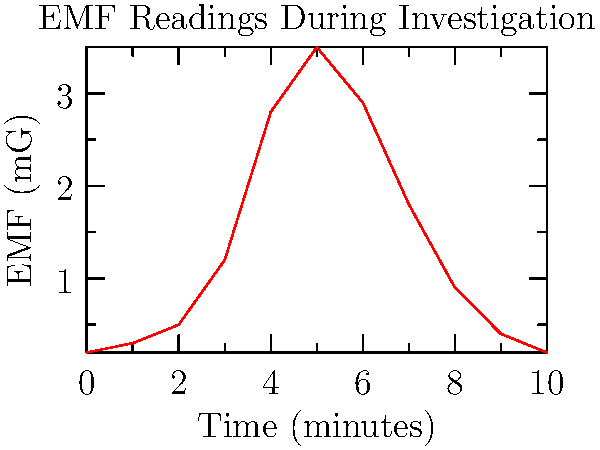During a paranormal investigation in an abandoned mine in West Virginia, you recorded EMF readings over a 10-minute period as shown in the graph. At what time interval did the most significant paranormal activity likely occur, based on the EMF spike? To determine the time interval of the most significant paranormal activity:

1. Analyze the graph to identify the highest peak in EMF readings.
2. The y-axis represents EMF strength in milligauss (mG).
3. The x-axis represents time in minutes.
4. The graph shows a clear spike in EMF readings.
5. The peak occurs between 4 and 6 minutes.
6. The highest point is at approximately 5 minutes, with a reading of about 3.5 mG.
7. In paranormal investigations, sudden spikes in EMF are often associated with potential supernatural activity.
8. The interval from 4 to 6 minutes shows the most dramatic increase and decrease in EMF.

Therefore, the most significant paranormal activity likely occurred between 4 and 6 minutes into the investigation.
Answer: 4-6 minutes 